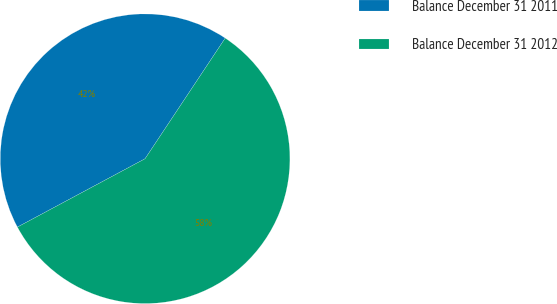<chart> <loc_0><loc_0><loc_500><loc_500><pie_chart><fcel>Balance December 31 2011<fcel>Balance December 31 2012<nl><fcel>42.16%<fcel>57.84%<nl></chart> 